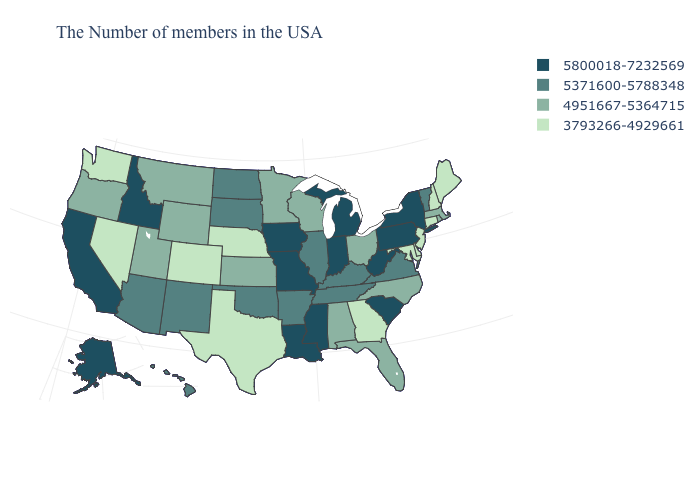Is the legend a continuous bar?
Concise answer only. No. Among the states that border Maine , which have the lowest value?
Concise answer only. New Hampshire. What is the value of Oklahoma?
Keep it brief. 5371600-5788348. Does Ohio have the same value as Missouri?
Write a very short answer. No. Name the states that have a value in the range 5371600-5788348?
Be succinct. Vermont, Virginia, Kentucky, Tennessee, Illinois, Arkansas, Oklahoma, South Dakota, North Dakota, New Mexico, Arizona, Hawaii. How many symbols are there in the legend?
Give a very brief answer. 4. Does Nebraska have the lowest value in the MidWest?
Quick response, please. Yes. What is the value of Arizona?
Write a very short answer. 5371600-5788348. Name the states that have a value in the range 3793266-4929661?
Be succinct. Maine, New Hampshire, Connecticut, New Jersey, Delaware, Maryland, Georgia, Nebraska, Texas, Colorado, Nevada, Washington. Name the states that have a value in the range 5371600-5788348?
Be succinct. Vermont, Virginia, Kentucky, Tennessee, Illinois, Arkansas, Oklahoma, South Dakota, North Dakota, New Mexico, Arizona, Hawaii. Does Connecticut have the lowest value in the Northeast?
Keep it brief. Yes. Among the states that border Louisiana , which have the lowest value?
Give a very brief answer. Texas. What is the value of New Hampshire?
Answer briefly. 3793266-4929661. Name the states that have a value in the range 5800018-7232569?
Give a very brief answer. New York, Pennsylvania, South Carolina, West Virginia, Michigan, Indiana, Mississippi, Louisiana, Missouri, Iowa, Idaho, California, Alaska. 